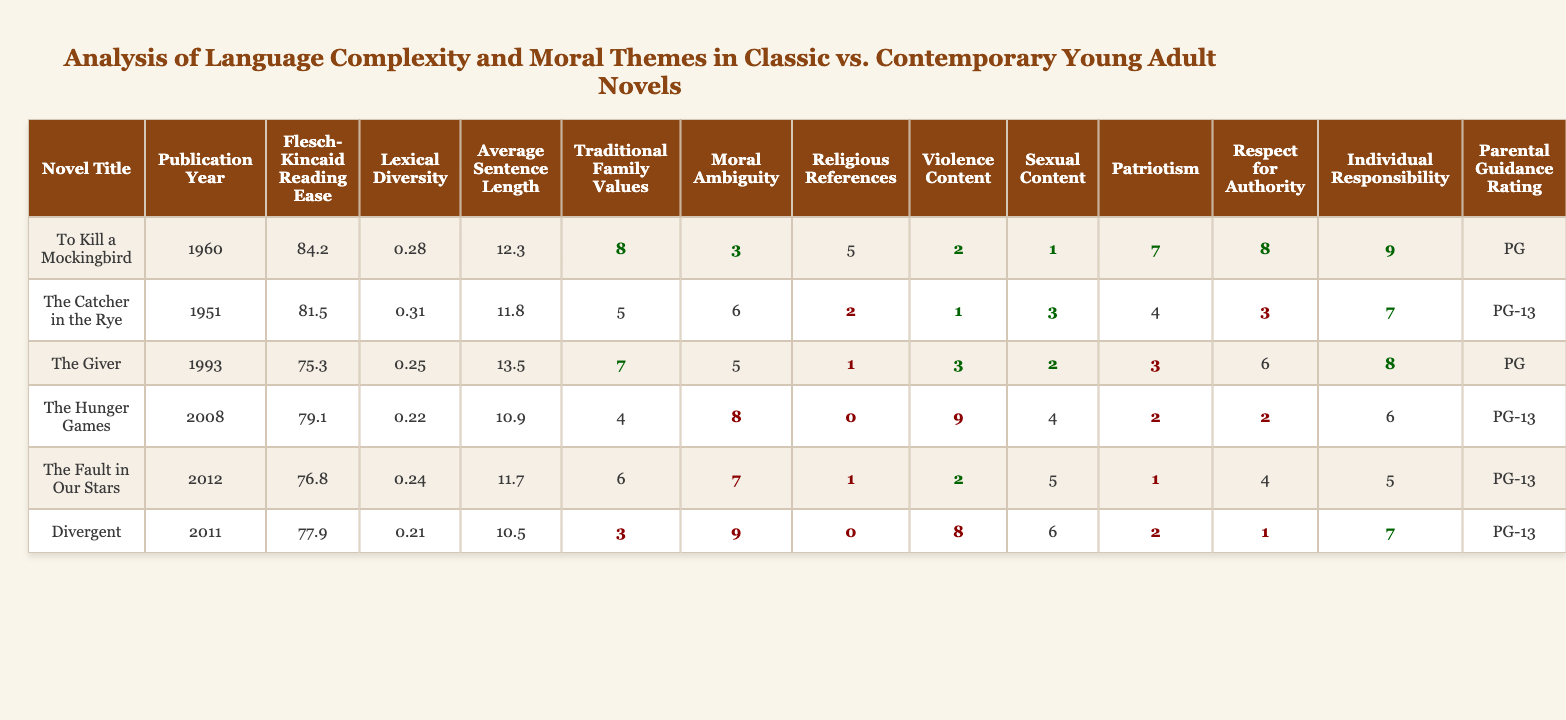What is the Flesch-Kincaid Reading Ease score for "To Kill a Mockingbird"? The Flesch-Kincaid Reading Ease score for "To Kill a Mockingbird" can be found in the relevant column of the table. It shows a score of 84.2.
Answer: 84.2 Which novel has the highest violence content? By examining the Violence Content column, "The Hunger Games" has the highest value at 9.
Answer: The Hunger Games What is the average sentence length for contemporary novels? The contemporary novels in the table are "The Hunger Games," "The Fault in Our Stars," "Divergent." Calculating the average sentence length: (10.9 + 11.7 + 10.5) / 3 = 11.0.
Answer: 11.0 Is "Divergent" rated PG-13 for parental guidance? Checking the Parental Guidance Rating column, "Divergent" is indeed rated PG-13.
Answer: Yes What is the difference in Traditional Family Values between "To Kill a Mockingbird" and "Divergent"? The value for "To Kill a Mockingbird" is 8 and for "Divergent" is 3. The difference is 8 - 3 = 5.
Answer: 5 Which novel shows the least respect for authority and what is that value? "Divergent" shows the least respect for authority with a value of 1.
Answer: 1 What is the median score for Moral Ambiguity among these novels? Listing the Moral Ambiguity scores in order: 3, 5, 5, 6, 7, 8, 9. The median is the average of the 3rd and 4th values (5 + 6) / 2 = 5.5.
Answer: 5.5 How many novels have a Sexual Content rating of 3 or lower? Looking at the Sexual Content column, the novels with a rating of 3 or lower are "The Catcher in the Rye" (3) and "To Kill a Mockingbird" (1), totaling 2 novels.
Answer: 2 Is there a correlation between the Flesch-Kincaid Reading Ease and the average sentence length across all titles? Analyzing the values: High Reading Ease scores do not necessarily correspond to shorter average sentence lengths. For instance, "To Kill a Mockingbird" has a high score but a longer average sentence length compared to "Divergent" which has a lower score and shorter average sentence length. While not directly correlated, they vary independently.
Answer: No clear correlation Which contemporary novel has the highest score in Moral Ambiguity? Among contemporary novels ("The Hunger Games," "The Fault in Our Stars," and "Divergent"), "Divergent" has the highest Moral Ambiguity score of 9.
Answer: Divergent 